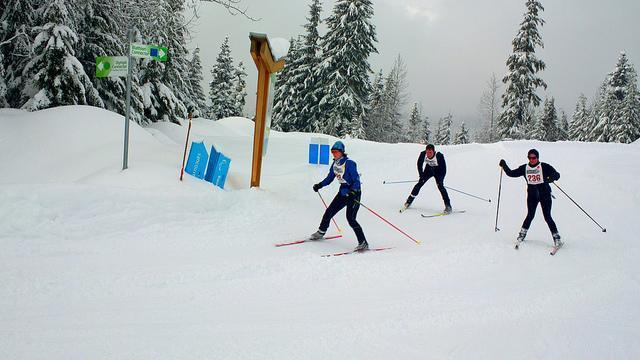How many people can be seen?
Give a very brief answer. 2. How many train tracks are in this picture?
Give a very brief answer. 0. 